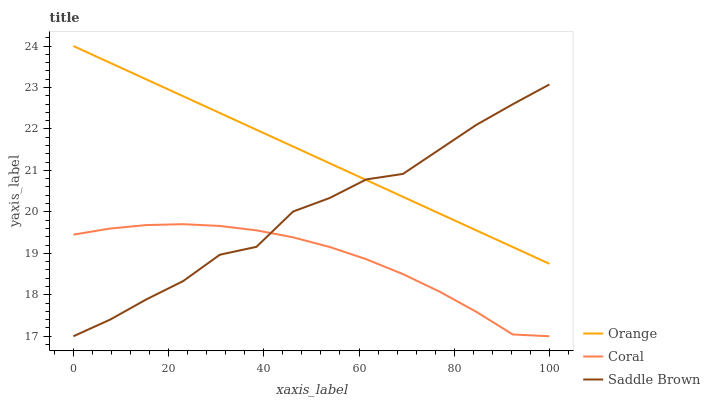Does Saddle Brown have the minimum area under the curve?
Answer yes or no. No. Does Saddle Brown have the maximum area under the curve?
Answer yes or no. No. Is Coral the smoothest?
Answer yes or no. No. Is Coral the roughest?
Answer yes or no. No. Does Saddle Brown have the highest value?
Answer yes or no. No. Is Coral less than Orange?
Answer yes or no. Yes. Is Orange greater than Coral?
Answer yes or no. Yes. Does Coral intersect Orange?
Answer yes or no. No. 